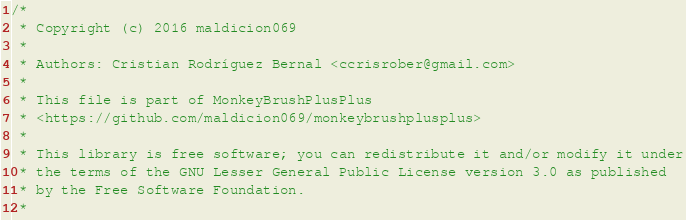<code> <loc_0><loc_0><loc_500><loc_500><_C++_>/*
 * Copyright (c) 2016 maldicion069
 *
 * Authors: Cristian Rodríguez Bernal <ccrisrober@gmail.com>
 *
 * This file is part of MonkeyBrushPlusPlus
 * <https://github.com/maldicion069/monkeybrushplusplus>
 *
 * This library is free software; you can redistribute it and/or modify it under
 * the terms of the GNU Lesser General Public License version 3.0 as published
 * by the Free Software Foundation.
 *</code> 